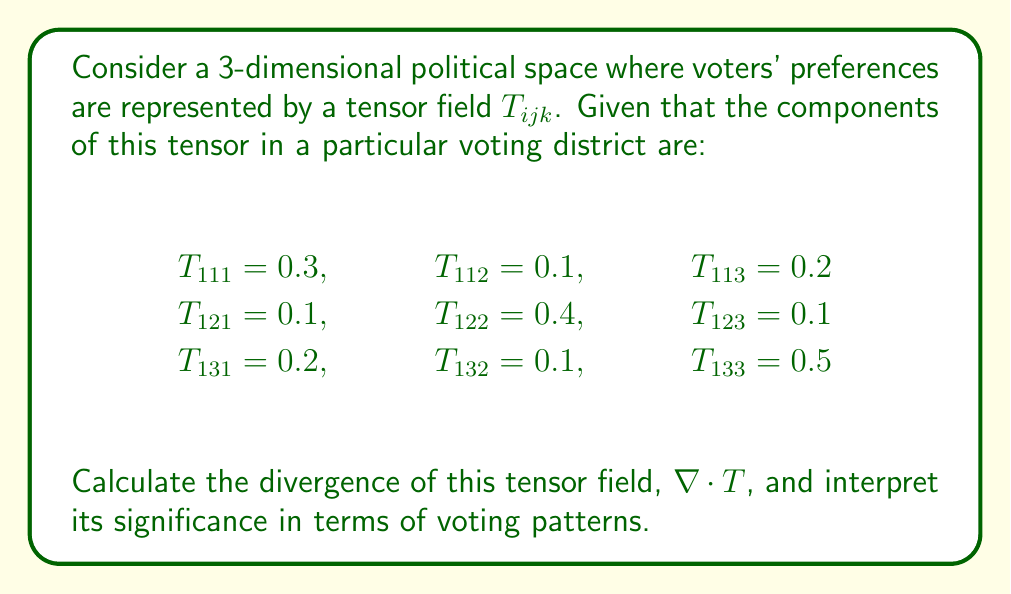Teach me how to tackle this problem. To solve this problem, we'll follow these steps:

1) The divergence of a 3rd-order tensor in 3D space is given by:

   $$(\nabla \cdot T)_{ij} = \frac{\partial T_{ijk}}{\partial x_k}$$

2) In this case, we need to calculate:

   $$(\nabla \cdot T)_{11} = \frac{\partial T_{111}}{\partial x_1} + \frac{\partial T_{112}}{\partial x_2} + \frac{\partial T_{113}}{\partial x_3}$$
   $$(\nabla \cdot T)_{12} = \frac{\partial T_{121}}{\partial x_1} + \frac{\partial T_{122}}{\partial x_2} + \frac{\partial T_{123}}{\partial x_3}$$
   $$(\nabla \cdot T)_{13} = \frac{\partial T_{131}}{\partial x_1} + \frac{\partial T_{132}}{\partial x_2} + \frac{\partial T_{133}}{\partial x_3}$$

3) Given the constant values of the tensor components, their partial derivatives will be zero. Therefore:

   $$(\nabla \cdot T)_{11} = 0 + 0 + 0 = 0$$
   $$(\nabla \cdot T)_{12} = 0 + 0 + 0 = 0$$
   $$(\nabla \cdot T)_{13} = 0 + 0 + 0 = 0$$

4) Thus, the divergence of the tensor field is a zero tensor:

   $$\nabla \cdot T = \begin{pmatrix} 0 & 0 & 0 \\ 0 & 0 & 0 \\ 0 & 0 & 0 \end{pmatrix}$$

5) Interpretation: The zero divergence indicates that there is no net "outflow" or "inflow" of voting preferences in this political space. This suggests a stable voting pattern where preferences are not shifting dramatically in any particular direction. It could imply a politically balanced district or a lack of external influences changing voter opinions.
Answer: $\nabla \cdot T = 0$ (zero tensor) 